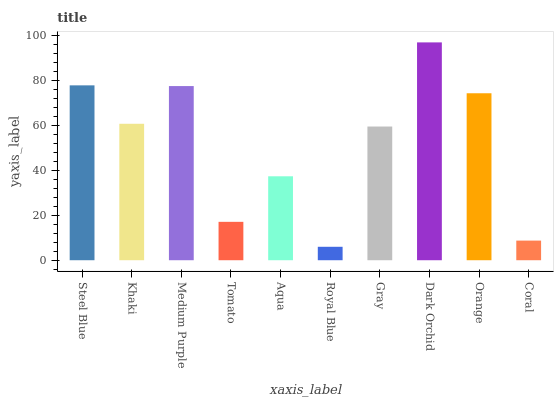Is Royal Blue the minimum?
Answer yes or no. Yes. Is Dark Orchid the maximum?
Answer yes or no. Yes. Is Khaki the minimum?
Answer yes or no. No. Is Khaki the maximum?
Answer yes or no. No. Is Steel Blue greater than Khaki?
Answer yes or no. Yes. Is Khaki less than Steel Blue?
Answer yes or no. Yes. Is Khaki greater than Steel Blue?
Answer yes or no. No. Is Steel Blue less than Khaki?
Answer yes or no. No. Is Khaki the high median?
Answer yes or no. Yes. Is Gray the low median?
Answer yes or no. Yes. Is Aqua the high median?
Answer yes or no. No. Is Royal Blue the low median?
Answer yes or no. No. 